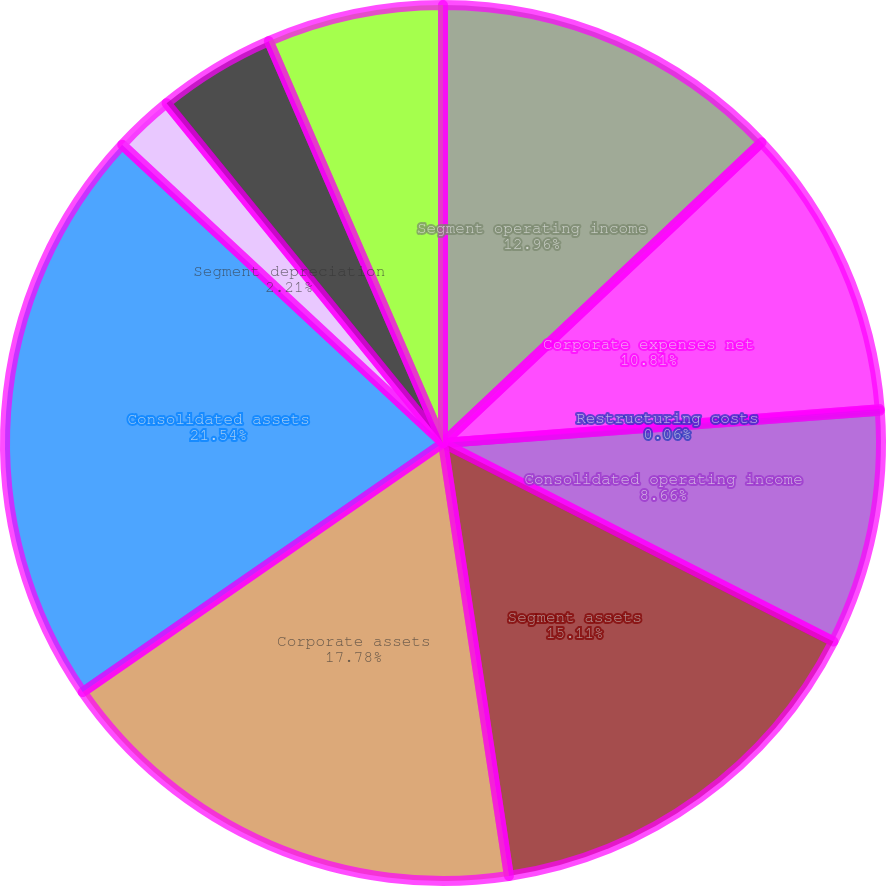<chart> <loc_0><loc_0><loc_500><loc_500><pie_chart><fcel>Segment operating income<fcel>Corporate expenses net<fcel>Restructuring costs<fcel>Consolidated operating income<fcel>Segment assets<fcel>Corporate assets<fcel>Consolidated assets<fcel>Segment depreciation<fcel>Corporate depreciation<fcel>Consolidated depreciation<nl><fcel>12.96%<fcel>10.81%<fcel>0.06%<fcel>8.66%<fcel>15.11%<fcel>17.78%<fcel>21.55%<fcel>2.21%<fcel>4.36%<fcel>6.51%<nl></chart> 